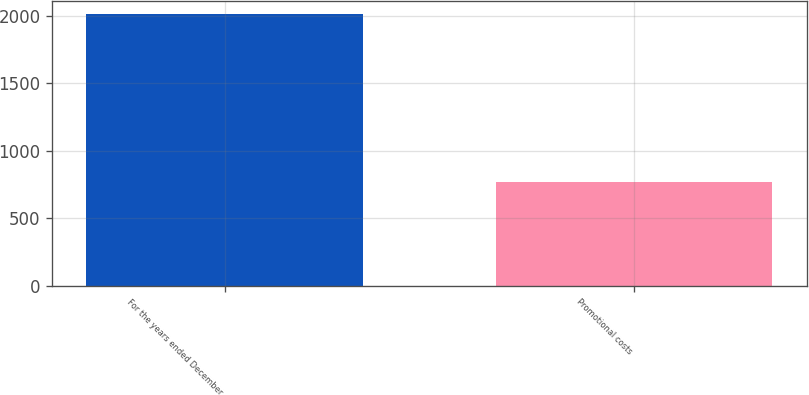Convert chart to OTSL. <chart><loc_0><loc_0><loc_500><loc_500><bar_chart><fcel>For the years ended December<fcel>Promotional costs<nl><fcel>2010<fcel>767.6<nl></chart> 